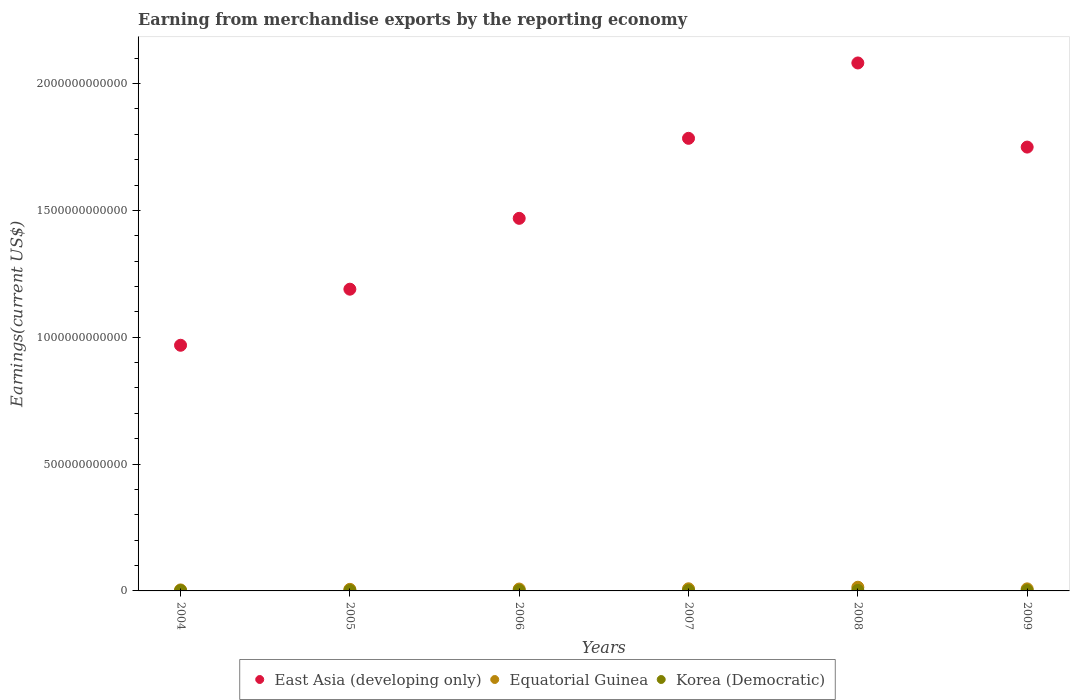What is the amount earned from merchandise exports in Equatorial Guinea in 2009?
Your answer should be compact. 8.09e+09. Across all years, what is the maximum amount earned from merchandise exports in Equatorial Guinea?
Offer a terse response. 1.46e+1. Across all years, what is the minimum amount earned from merchandise exports in Korea (Democratic)?
Your response must be concise. 1.15e+09. What is the total amount earned from merchandise exports in Korea (Democratic) in the graph?
Offer a terse response. 8.89e+09. What is the difference between the amount earned from merchandise exports in Equatorial Guinea in 2005 and that in 2006?
Provide a short and direct response. -1.27e+09. What is the difference between the amount earned from merchandise exports in Equatorial Guinea in 2006 and the amount earned from merchandise exports in East Asia (developing only) in 2007?
Your answer should be very brief. -1.78e+12. What is the average amount earned from merchandise exports in Equatorial Guinea per year?
Provide a succinct answer. 8.11e+09. In the year 2005, what is the difference between the amount earned from merchandise exports in East Asia (developing only) and amount earned from merchandise exports in Korea (Democratic)?
Your response must be concise. 1.19e+12. In how many years, is the amount earned from merchandise exports in Korea (Democratic) greater than 1700000000000 US$?
Your response must be concise. 0. What is the ratio of the amount earned from merchandise exports in Equatorial Guinea in 2007 to that in 2008?
Keep it short and to the point. 0.58. Is the difference between the amount earned from merchandise exports in East Asia (developing only) in 2005 and 2007 greater than the difference between the amount earned from merchandise exports in Korea (Democratic) in 2005 and 2007?
Keep it short and to the point. No. What is the difference between the highest and the second highest amount earned from merchandise exports in East Asia (developing only)?
Keep it short and to the point. 2.97e+11. What is the difference between the highest and the lowest amount earned from merchandise exports in East Asia (developing only)?
Your answer should be very brief. 1.11e+12. In how many years, is the amount earned from merchandise exports in Korea (Democratic) greater than the average amount earned from merchandise exports in Korea (Democratic) taken over all years?
Make the answer very short. 3. Does the amount earned from merchandise exports in Equatorial Guinea monotonically increase over the years?
Your answer should be very brief. No. Is the amount earned from merchandise exports in Equatorial Guinea strictly greater than the amount earned from merchandise exports in East Asia (developing only) over the years?
Offer a terse response. No. How many dotlines are there?
Your answer should be very brief. 3. What is the difference between two consecutive major ticks on the Y-axis?
Your answer should be compact. 5.00e+11. Does the graph contain grids?
Keep it short and to the point. No. Where does the legend appear in the graph?
Offer a very short reply. Bottom center. How many legend labels are there?
Keep it short and to the point. 3. What is the title of the graph?
Offer a very short reply. Earning from merchandise exports by the reporting economy. Does "Oman" appear as one of the legend labels in the graph?
Your response must be concise. No. What is the label or title of the Y-axis?
Give a very brief answer. Earnings(current US$). What is the Earnings(current US$) in East Asia (developing only) in 2004?
Ensure brevity in your answer.  9.68e+11. What is the Earnings(current US$) of Equatorial Guinea in 2004?
Offer a very short reply. 3.95e+09. What is the Earnings(current US$) in Korea (Democratic) in 2004?
Your answer should be compact. 1.15e+09. What is the Earnings(current US$) in East Asia (developing only) in 2005?
Offer a very short reply. 1.19e+12. What is the Earnings(current US$) of Equatorial Guinea in 2005?
Your answer should be very brief. 6.19e+09. What is the Earnings(current US$) of Korea (Democratic) in 2005?
Keep it short and to the point. 1.20e+09. What is the Earnings(current US$) in East Asia (developing only) in 2006?
Ensure brevity in your answer.  1.47e+12. What is the Earnings(current US$) of Equatorial Guinea in 2006?
Your response must be concise. 7.46e+09. What is the Earnings(current US$) in Korea (Democratic) in 2006?
Your answer should be very brief. 1.52e+09. What is the Earnings(current US$) in East Asia (developing only) in 2007?
Offer a very short reply. 1.78e+12. What is the Earnings(current US$) in Equatorial Guinea in 2007?
Ensure brevity in your answer.  8.42e+09. What is the Earnings(current US$) in Korea (Democratic) in 2007?
Your response must be concise. 1.62e+09. What is the Earnings(current US$) in East Asia (developing only) in 2008?
Offer a very short reply. 2.08e+12. What is the Earnings(current US$) in Equatorial Guinea in 2008?
Your answer should be compact. 1.46e+1. What is the Earnings(current US$) of Korea (Democratic) in 2008?
Give a very brief answer. 1.95e+09. What is the Earnings(current US$) of East Asia (developing only) in 2009?
Ensure brevity in your answer.  1.75e+12. What is the Earnings(current US$) of Equatorial Guinea in 2009?
Offer a terse response. 8.09e+09. What is the Earnings(current US$) of Korea (Democratic) in 2009?
Provide a succinct answer. 1.44e+09. Across all years, what is the maximum Earnings(current US$) of East Asia (developing only)?
Make the answer very short. 2.08e+12. Across all years, what is the maximum Earnings(current US$) in Equatorial Guinea?
Offer a very short reply. 1.46e+1. Across all years, what is the maximum Earnings(current US$) of Korea (Democratic)?
Ensure brevity in your answer.  1.95e+09. Across all years, what is the minimum Earnings(current US$) in East Asia (developing only)?
Ensure brevity in your answer.  9.68e+11. Across all years, what is the minimum Earnings(current US$) in Equatorial Guinea?
Your response must be concise. 3.95e+09. Across all years, what is the minimum Earnings(current US$) of Korea (Democratic)?
Your answer should be very brief. 1.15e+09. What is the total Earnings(current US$) in East Asia (developing only) in the graph?
Offer a terse response. 9.24e+12. What is the total Earnings(current US$) in Equatorial Guinea in the graph?
Provide a short and direct response. 4.87e+1. What is the total Earnings(current US$) of Korea (Democratic) in the graph?
Your answer should be very brief. 8.89e+09. What is the difference between the Earnings(current US$) in East Asia (developing only) in 2004 and that in 2005?
Offer a very short reply. -2.21e+11. What is the difference between the Earnings(current US$) of Equatorial Guinea in 2004 and that in 2005?
Provide a short and direct response. -2.24e+09. What is the difference between the Earnings(current US$) of Korea (Democratic) in 2004 and that in 2005?
Ensure brevity in your answer.  -5.10e+07. What is the difference between the Earnings(current US$) in East Asia (developing only) in 2004 and that in 2006?
Offer a terse response. -5.00e+11. What is the difference between the Earnings(current US$) in Equatorial Guinea in 2004 and that in 2006?
Keep it short and to the point. -3.51e+09. What is the difference between the Earnings(current US$) in Korea (Democratic) in 2004 and that in 2006?
Provide a short and direct response. -3.72e+08. What is the difference between the Earnings(current US$) of East Asia (developing only) in 2004 and that in 2007?
Provide a succinct answer. -8.16e+11. What is the difference between the Earnings(current US$) in Equatorial Guinea in 2004 and that in 2007?
Make the answer very short. -4.47e+09. What is the difference between the Earnings(current US$) of Korea (Democratic) in 2004 and that in 2007?
Offer a terse response. -4.69e+08. What is the difference between the Earnings(current US$) of East Asia (developing only) in 2004 and that in 2008?
Offer a very short reply. -1.11e+12. What is the difference between the Earnings(current US$) in Equatorial Guinea in 2004 and that in 2008?
Offer a very short reply. -1.06e+1. What is the difference between the Earnings(current US$) of Korea (Democratic) in 2004 and that in 2008?
Provide a succinct answer. -8.04e+08. What is the difference between the Earnings(current US$) of East Asia (developing only) in 2004 and that in 2009?
Your answer should be compact. -7.81e+11. What is the difference between the Earnings(current US$) of Equatorial Guinea in 2004 and that in 2009?
Provide a short and direct response. -4.14e+09. What is the difference between the Earnings(current US$) of Korea (Democratic) in 2004 and that in 2009?
Offer a very short reply. -2.91e+08. What is the difference between the Earnings(current US$) in East Asia (developing only) in 2005 and that in 2006?
Your answer should be compact. -2.79e+11. What is the difference between the Earnings(current US$) of Equatorial Guinea in 2005 and that in 2006?
Your answer should be very brief. -1.27e+09. What is the difference between the Earnings(current US$) of Korea (Democratic) in 2005 and that in 2006?
Keep it short and to the point. -3.21e+08. What is the difference between the Earnings(current US$) in East Asia (developing only) in 2005 and that in 2007?
Provide a succinct answer. -5.95e+11. What is the difference between the Earnings(current US$) in Equatorial Guinea in 2005 and that in 2007?
Your answer should be compact. -2.23e+09. What is the difference between the Earnings(current US$) in Korea (Democratic) in 2005 and that in 2007?
Provide a short and direct response. -4.18e+08. What is the difference between the Earnings(current US$) of East Asia (developing only) in 2005 and that in 2008?
Your answer should be compact. -8.92e+11. What is the difference between the Earnings(current US$) in Equatorial Guinea in 2005 and that in 2008?
Offer a very short reply. -8.38e+09. What is the difference between the Earnings(current US$) in Korea (Democratic) in 2005 and that in 2008?
Your response must be concise. -7.53e+08. What is the difference between the Earnings(current US$) in East Asia (developing only) in 2005 and that in 2009?
Offer a terse response. -5.60e+11. What is the difference between the Earnings(current US$) in Equatorial Guinea in 2005 and that in 2009?
Ensure brevity in your answer.  -1.90e+09. What is the difference between the Earnings(current US$) in Korea (Democratic) in 2005 and that in 2009?
Ensure brevity in your answer.  -2.40e+08. What is the difference between the Earnings(current US$) of East Asia (developing only) in 2006 and that in 2007?
Provide a short and direct response. -3.15e+11. What is the difference between the Earnings(current US$) in Equatorial Guinea in 2006 and that in 2007?
Keep it short and to the point. -9.59e+08. What is the difference between the Earnings(current US$) of Korea (Democratic) in 2006 and that in 2007?
Keep it short and to the point. -9.70e+07. What is the difference between the Earnings(current US$) of East Asia (developing only) in 2006 and that in 2008?
Ensure brevity in your answer.  -6.12e+11. What is the difference between the Earnings(current US$) in Equatorial Guinea in 2006 and that in 2008?
Your response must be concise. -7.11e+09. What is the difference between the Earnings(current US$) in Korea (Democratic) in 2006 and that in 2008?
Your answer should be very brief. -4.31e+08. What is the difference between the Earnings(current US$) in East Asia (developing only) in 2006 and that in 2009?
Ensure brevity in your answer.  -2.81e+11. What is the difference between the Earnings(current US$) of Equatorial Guinea in 2006 and that in 2009?
Your answer should be very brief. -6.29e+08. What is the difference between the Earnings(current US$) in Korea (Democratic) in 2006 and that in 2009?
Give a very brief answer. 8.17e+07. What is the difference between the Earnings(current US$) of East Asia (developing only) in 2007 and that in 2008?
Your response must be concise. -2.97e+11. What is the difference between the Earnings(current US$) in Equatorial Guinea in 2007 and that in 2008?
Make the answer very short. -6.15e+09. What is the difference between the Earnings(current US$) of Korea (Democratic) in 2007 and that in 2008?
Your answer should be compact. -3.34e+08. What is the difference between the Earnings(current US$) of East Asia (developing only) in 2007 and that in 2009?
Make the answer very short. 3.45e+1. What is the difference between the Earnings(current US$) of Equatorial Guinea in 2007 and that in 2009?
Give a very brief answer. 3.29e+08. What is the difference between the Earnings(current US$) of Korea (Democratic) in 2007 and that in 2009?
Offer a very short reply. 1.79e+08. What is the difference between the Earnings(current US$) in East Asia (developing only) in 2008 and that in 2009?
Give a very brief answer. 3.32e+11. What is the difference between the Earnings(current US$) in Equatorial Guinea in 2008 and that in 2009?
Your response must be concise. 6.48e+09. What is the difference between the Earnings(current US$) of Korea (Democratic) in 2008 and that in 2009?
Your response must be concise. 5.13e+08. What is the difference between the Earnings(current US$) of East Asia (developing only) in 2004 and the Earnings(current US$) of Equatorial Guinea in 2005?
Provide a short and direct response. 9.62e+11. What is the difference between the Earnings(current US$) of East Asia (developing only) in 2004 and the Earnings(current US$) of Korea (Democratic) in 2005?
Offer a terse response. 9.67e+11. What is the difference between the Earnings(current US$) in Equatorial Guinea in 2004 and the Earnings(current US$) in Korea (Democratic) in 2005?
Your response must be concise. 2.75e+09. What is the difference between the Earnings(current US$) in East Asia (developing only) in 2004 and the Earnings(current US$) in Equatorial Guinea in 2006?
Your response must be concise. 9.61e+11. What is the difference between the Earnings(current US$) in East Asia (developing only) in 2004 and the Earnings(current US$) in Korea (Democratic) in 2006?
Provide a short and direct response. 9.67e+11. What is the difference between the Earnings(current US$) in Equatorial Guinea in 2004 and the Earnings(current US$) in Korea (Democratic) in 2006?
Your answer should be compact. 2.43e+09. What is the difference between the Earnings(current US$) of East Asia (developing only) in 2004 and the Earnings(current US$) of Equatorial Guinea in 2007?
Your answer should be very brief. 9.60e+11. What is the difference between the Earnings(current US$) of East Asia (developing only) in 2004 and the Earnings(current US$) of Korea (Democratic) in 2007?
Provide a succinct answer. 9.67e+11. What is the difference between the Earnings(current US$) of Equatorial Guinea in 2004 and the Earnings(current US$) of Korea (Democratic) in 2007?
Give a very brief answer. 2.33e+09. What is the difference between the Earnings(current US$) in East Asia (developing only) in 2004 and the Earnings(current US$) in Equatorial Guinea in 2008?
Offer a terse response. 9.54e+11. What is the difference between the Earnings(current US$) of East Asia (developing only) in 2004 and the Earnings(current US$) of Korea (Democratic) in 2008?
Give a very brief answer. 9.66e+11. What is the difference between the Earnings(current US$) of Equatorial Guinea in 2004 and the Earnings(current US$) of Korea (Democratic) in 2008?
Ensure brevity in your answer.  2.00e+09. What is the difference between the Earnings(current US$) in East Asia (developing only) in 2004 and the Earnings(current US$) in Equatorial Guinea in 2009?
Keep it short and to the point. 9.60e+11. What is the difference between the Earnings(current US$) of East Asia (developing only) in 2004 and the Earnings(current US$) of Korea (Democratic) in 2009?
Ensure brevity in your answer.  9.67e+11. What is the difference between the Earnings(current US$) of Equatorial Guinea in 2004 and the Earnings(current US$) of Korea (Democratic) in 2009?
Keep it short and to the point. 2.51e+09. What is the difference between the Earnings(current US$) in East Asia (developing only) in 2005 and the Earnings(current US$) in Equatorial Guinea in 2006?
Offer a very short reply. 1.18e+12. What is the difference between the Earnings(current US$) of East Asia (developing only) in 2005 and the Earnings(current US$) of Korea (Democratic) in 2006?
Your answer should be compact. 1.19e+12. What is the difference between the Earnings(current US$) of Equatorial Guinea in 2005 and the Earnings(current US$) of Korea (Democratic) in 2006?
Keep it short and to the point. 4.67e+09. What is the difference between the Earnings(current US$) in East Asia (developing only) in 2005 and the Earnings(current US$) in Equatorial Guinea in 2007?
Your answer should be very brief. 1.18e+12. What is the difference between the Earnings(current US$) in East Asia (developing only) in 2005 and the Earnings(current US$) in Korea (Democratic) in 2007?
Offer a very short reply. 1.19e+12. What is the difference between the Earnings(current US$) in Equatorial Guinea in 2005 and the Earnings(current US$) in Korea (Democratic) in 2007?
Give a very brief answer. 4.57e+09. What is the difference between the Earnings(current US$) of East Asia (developing only) in 2005 and the Earnings(current US$) of Equatorial Guinea in 2008?
Ensure brevity in your answer.  1.17e+12. What is the difference between the Earnings(current US$) in East Asia (developing only) in 2005 and the Earnings(current US$) in Korea (Democratic) in 2008?
Provide a short and direct response. 1.19e+12. What is the difference between the Earnings(current US$) in Equatorial Guinea in 2005 and the Earnings(current US$) in Korea (Democratic) in 2008?
Your answer should be compact. 4.24e+09. What is the difference between the Earnings(current US$) in East Asia (developing only) in 2005 and the Earnings(current US$) in Equatorial Guinea in 2009?
Provide a short and direct response. 1.18e+12. What is the difference between the Earnings(current US$) of East Asia (developing only) in 2005 and the Earnings(current US$) of Korea (Democratic) in 2009?
Make the answer very short. 1.19e+12. What is the difference between the Earnings(current US$) in Equatorial Guinea in 2005 and the Earnings(current US$) in Korea (Democratic) in 2009?
Offer a very short reply. 4.75e+09. What is the difference between the Earnings(current US$) in East Asia (developing only) in 2006 and the Earnings(current US$) in Equatorial Guinea in 2007?
Provide a succinct answer. 1.46e+12. What is the difference between the Earnings(current US$) in East Asia (developing only) in 2006 and the Earnings(current US$) in Korea (Democratic) in 2007?
Offer a terse response. 1.47e+12. What is the difference between the Earnings(current US$) of Equatorial Guinea in 2006 and the Earnings(current US$) of Korea (Democratic) in 2007?
Provide a succinct answer. 5.84e+09. What is the difference between the Earnings(current US$) of East Asia (developing only) in 2006 and the Earnings(current US$) of Equatorial Guinea in 2008?
Provide a succinct answer. 1.45e+12. What is the difference between the Earnings(current US$) of East Asia (developing only) in 2006 and the Earnings(current US$) of Korea (Democratic) in 2008?
Provide a succinct answer. 1.47e+12. What is the difference between the Earnings(current US$) of Equatorial Guinea in 2006 and the Earnings(current US$) of Korea (Democratic) in 2008?
Offer a terse response. 5.51e+09. What is the difference between the Earnings(current US$) in East Asia (developing only) in 2006 and the Earnings(current US$) in Equatorial Guinea in 2009?
Make the answer very short. 1.46e+12. What is the difference between the Earnings(current US$) in East Asia (developing only) in 2006 and the Earnings(current US$) in Korea (Democratic) in 2009?
Make the answer very short. 1.47e+12. What is the difference between the Earnings(current US$) of Equatorial Guinea in 2006 and the Earnings(current US$) of Korea (Democratic) in 2009?
Ensure brevity in your answer.  6.02e+09. What is the difference between the Earnings(current US$) in East Asia (developing only) in 2007 and the Earnings(current US$) in Equatorial Guinea in 2008?
Your answer should be compact. 1.77e+12. What is the difference between the Earnings(current US$) in East Asia (developing only) in 2007 and the Earnings(current US$) in Korea (Democratic) in 2008?
Your answer should be very brief. 1.78e+12. What is the difference between the Earnings(current US$) in Equatorial Guinea in 2007 and the Earnings(current US$) in Korea (Democratic) in 2008?
Give a very brief answer. 6.46e+09. What is the difference between the Earnings(current US$) in East Asia (developing only) in 2007 and the Earnings(current US$) in Equatorial Guinea in 2009?
Your answer should be compact. 1.78e+12. What is the difference between the Earnings(current US$) of East Asia (developing only) in 2007 and the Earnings(current US$) of Korea (Democratic) in 2009?
Ensure brevity in your answer.  1.78e+12. What is the difference between the Earnings(current US$) in Equatorial Guinea in 2007 and the Earnings(current US$) in Korea (Democratic) in 2009?
Give a very brief answer. 6.98e+09. What is the difference between the Earnings(current US$) in East Asia (developing only) in 2008 and the Earnings(current US$) in Equatorial Guinea in 2009?
Provide a succinct answer. 2.07e+12. What is the difference between the Earnings(current US$) of East Asia (developing only) in 2008 and the Earnings(current US$) of Korea (Democratic) in 2009?
Keep it short and to the point. 2.08e+12. What is the difference between the Earnings(current US$) in Equatorial Guinea in 2008 and the Earnings(current US$) in Korea (Democratic) in 2009?
Provide a succinct answer. 1.31e+1. What is the average Earnings(current US$) of East Asia (developing only) per year?
Provide a succinct answer. 1.54e+12. What is the average Earnings(current US$) in Equatorial Guinea per year?
Ensure brevity in your answer.  8.11e+09. What is the average Earnings(current US$) of Korea (Democratic) per year?
Make the answer very short. 1.48e+09. In the year 2004, what is the difference between the Earnings(current US$) of East Asia (developing only) and Earnings(current US$) of Equatorial Guinea?
Provide a succinct answer. 9.64e+11. In the year 2004, what is the difference between the Earnings(current US$) in East Asia (developing only) and Earnings(current US$) in Korea (Democratic)?
Provide a succinct answer. 9.67e+11. In the year 2004, what is the difference between the Earnings(current US$) of Equatorial Guinea and Earnings(current US$) of Korea (Democratic)?
Provide a succinct answer. 2.80e+09. In the year 2005, what is the difference between the Earnings(current US$) of East Asia (developing only) and Earnings(current US$) of Equatorial Guinea?
Your response must be concise. 1.18e+12. In the year 2005, what is the difference between the Earnings(current US$) of East Asia (developing only) and Earnings(current US$) of Korea (Democratic)?
Your answer should be compact. 1.19e+12. In the year 2005, what is the difference between the Earnings(current US$) in Equatorial Guinea and Earnings(current US$) in Korea (Democratic)?
Offer a terse response. 4.99e+09. In the year 2006, what is the difference between the Earnings(current US$) in East Asia (developing only) and Earnings(current US$) in Equatorial Guinea?
Ensure brevity in your answer.  1.46e+12. In the year 2006, what is the difference between the Earnings(current US$) in East Asia (developing only) and Earnings(current US$) in Korea (Democratic)?
Your answer should be compact. 1.47e+12. In the year 2006, what is the difference between the Earnings(current US$) in Equatorial Guinea and Earnings(current US$) in Korea (Democratic)?
Your response must be concise. 5.94e+09. In the year 2007, what is the difference between the Earnings(current US$) in East Asia (developing only) and Earnings(current US$) in Equatorial Guinea?
Offer a terse response. 1.78e+12. In the year 2007, what is the difference between the Earnings(current US$) of East Asia (developing only) and Earnings(current US$) of Korea (Democratic)?
Ensure brevity in your answer.  1.78e+12. In the year 2007, what is the difference between the Earnings(current US$) of Equatorial Guinea and Earnings(current US$) of Korea (Democratic)?
Provide a succinct answer. 6.80e+09. In the year 2008, what is the difference between the Earnings(current US$) of East Asia (developing only) and Earnings(current US$) of Equatorial Guinea?
Offer a terse response. 2.07e+12. In the year 2008, what is the difference between the Earnings(current US$) of East Asia (developing only) and Earnings(current US$) of Korea (Democratic)?
Make the answer very short. 2.08e+12. In the year 2008, what is the difference between the Earnings(current US$) in Equatorial Guinea and Earnings(current US$) in Korea (Democratic)?
Your answer should be very brief. 1.26e+1. In the year 2009, what is the difference between the Earnings(current US$) of East Asia (developing only) and Earnings(current US$) of Equatorial Guinea?
Offer a very short reply. 1.74e+12. In the year 2009, what is the difference between the Earnings(current US$) of East Asia (developing only) and Earnings(current US$) of Korea (Democratic)?
Provide a succinct answer. 1.75e+12. In the year 2009, what is the difference between the Earnings(current US$) of Equatorial Guinea and Earnings(current US$) of Korea (Democratic)?
Ensure brevity in your answer.  6.65e+09. What is the ratio of the Earnings(current US$) of East Asia (developing only) in 2004 to that in 2005?
Offer a very short reply. 0.81. What is the ratio of the Earnings(current US$) in Equatorial Guinea in 2004 to that in 2005?
Provide a short and direct response. 0.64. What is the ratio of the Earnings(current US$) in Korea (Democratic) in 2004 to that in 2005?
Offer a terse response. 0.96. What is the ratio of the Earnings(current US$) of East Asia (developing only) in 2004 to that in 2006?
Offer a terse response. 0.66. What is the ratio of the Earnings(current US$) in Equatorial Guinea in 2004 to that in 2006?
Offer a terse response. 0.53. What is the ratio of the Earnings(current US$) in Korea (Democratic) in 2004 to that in 2006?
Give a very brief answer. 0.76. What is the ratio of the Earnings(current US$) of East Asia (developing only) in 2004 to that in 2007?
Offer a very short reply. 0.54. What is the ratio of the Earnings(current US$) in Equatorial Guinea in 2004 to that in 2007?
Give a very brief answer. 0.47. What is the ratio of the Earnings(current US$) of Korea (Democratic) in 2004 to that in 2007?
Offer a very short reply. 0.71. What is the ratio of the Earnings(current US$) of East Asia (developing only) in 2004 to that in 2008?
Provide a succinct answer. 0.47. What is the ratio of the Earnings(current US$) of Equatorial Guinea in 2004 to that in 2008?
Keep it short and to the point. 0.27. What is the ratio of the Earnings(current US$) in Korea (Democratic) in 2004 to that in 2008?
Provide a succinct answer. 0.59. What is the ratio of the Earnings(current US$) in East Asia (developing only) in 2004 to that in 2009?
Keep it short and to the point. 0.55. What is the ratio of the Earnings(current US$) in Equatorial Guinea in 2004 to that in 2009?
Keep it short and to the point. 0.49. What is the ratio of the Earnings(current US$) in Korea (Democratic) in 2004 to that in 2009?
Offer a very short reply. 0.8. What is the ratio of the Earnings(current US$) in East Asia (developing only) in 2005 to that in 2006?
Give a very brief answer. 0.81. What is the ratio of the Earnings(current US$) of Equatorial Guinea in 2005 to that in 2006?
Your answer should be very brief. 0.83. What is the ratio of the Earnings(current US$) in Korea (Democratic) in 2005 to that in 2006?
Ensure brevity in your answer.  0.79. What is the ratio of the Earnings(current US$) in Equatorial Guinea in 2005 to that in 2007?
Offer a terse response. 0.74. What is the ratio of the Earnings(current US$) of Korea (Democratic) in 2005 to that in 2007?
Your answer should be compact. 0.74. What is the ratio of the Earnings(current US$) of East Asia (developing only) in 2005 to that in 2008?
Provide a succinct answer. 0.57. What is the ratio of the Earnings(current US$) of Equatorial Guinea in 2005 to that in 2008?
Provide a short and direct response. 0.42. What is the ratio of the Earnings(current US$) in Korea (Democratic) in 2005 to that in 2008?
Give a very brief answer. 0.61. What is the ratio of the Earnings(current US$) in East Asia (developing only) in 2005 to that in 2009?
Offer a very short reply. 0.68. What is the ratio of the Earnings(current US$) of Equatorial Guinea in 2005 to that in 2009?
Your response must be concise. 0.77. What is the ratio of the Earnings(current US$) of Korea (Democratic) in 2005 to that in 2009?
Keep it short and to the point. 0.83. What is the ratio of the Earnings(current US$) of East Asia (developing only) in 2006 to that in 2007?
Give a very brief answer. 0.82. What is the ratio of the Earnings(current US$) in Equatorial Guinea in 2006 to that in 2007?
Keep it short and to the point. 0.89. What is the ratio of the Earnings(current US$) of Korea (Democratic) in 2006 to that in 2007?
Offer a very short reply. 0.94. What is the ratio of the Earnings(current US$) of East Asia (developing only) in 2006 to that in 2008?
Your answer should be very brief. 0.71. What is the ratio of the Earnings(current US$) of Equatorial Guinea in 2006 to that in 2008?
Offer a terse response. 0.51. What is the ratio of the Earnings(current US$) of Korea (Democratic) in 2006 to that in 2008?
Provide a succinct answer. 0.78. What is the ratio of the Earnings(current US$) of East Asia (developing only) in 2006 to that in 2009?
Provide a succinct answer. 0.84. What is the ratio of the Earnings(current US$) of Equatorial Guinea in 2006 to that in 2009?
Offer a terse response. 0.92. What is the ratio of the Earnings(current US$) of Korea (Democratic) in 2006 to that in 2009?
Give a very brief answer. 1.06. What is the ratio of the Earnings(current US$) in East Asia (developing only) in 2007 to that in 2008?
Your answer should be compact. 0.86. What is the ratio of the Earnings(current US$) of Equatorial Guinea in 2007 to that in 2008?
Give a very brief answer. 0.58. What is the ratio of the Earnings(current US$) of Korea (Democratic) in 2007 to that in 2008?
Give a very brief answer. 0.83. What is the ratio of the Earnings(current US$) of East Asia (developing only) in 2007 to that in 2009?
Provide a short and direct response. 1.02. What is the ratio of the Earnings(current US$) in Equatorial Guinea in 2007 to that in 2009?
Make the answer very short. 1.04. What is the ratio of the Earnings(current US$) in Korea (Democratic) in 2007 to that in 2009?
Your response must be concise. 1.12. What is the ratio of the Earnings(current US$) in East Asia (developing only) in 2008 to that in 2009?
Ensure brevity in your answer.  1.19. What is the ratio of the Earnings(current US$) of Equatorial Guinea in 2008 to that in 2009?
Ensure brevity in your answer.  1.8. What is the ratio of the Earnings(current US$) of Korea (Democratic) in 2008 to that in 2009?
Your answer should be compact. 1.36. What is the difference between the highest and the second highest Earnings(current US$) in East Asia (developing only)?
Provide a succinct answer. 2.97e+11. What is the difference between the highest and the second highest Earnings(current US$) in Equatorial Guinea?
Ensure brevity in your answer.  6.15e+09. What is the difference between the highest and the second highest Earnings(current US$) of Korea (Democratic)?
Your answer should be very brief. 3.34e+08. What is the difference between the highest and the lowest Earnings(current US$) in East Asia (developing only)?
Make the answer very short. 1.11e+12. What is the difference between the highest and the lowest Earnings(current US$) in Equatorial Guinea?
Your answer should be compact. 1.06e+1. What is the difference between the highest and the lowest Earnings(current US$) in Korea (Democratic)?
Make the answer very short. 8.04e+08. 